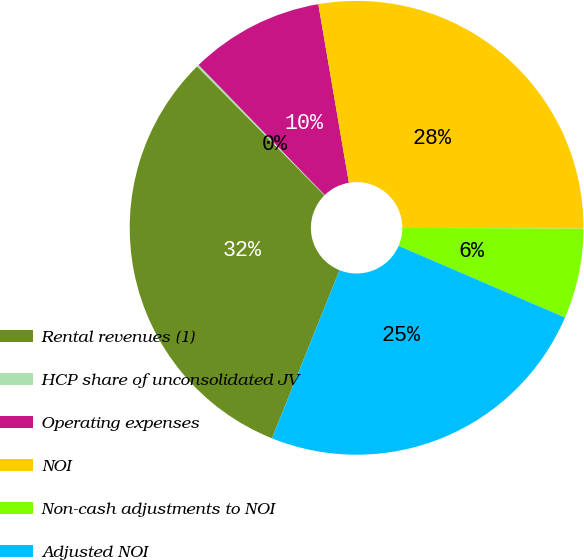Convert chart. <chart><loc_0><loc_0><loc_500><loc_500><pie_chart><fcel>Rental revenues (1)<fcel>HCP share of unconsolidated JV<fcel>Operating expenses<fcel>NOI<fcel>Non-cash adjustments to NOI<fcel>Adjusted NOI<nl><fcel>31.51%<fcel>0.15%<fcel>9.56%<fcel>27.75%<fcel>6.42%<fcel>24.61%<nl></chart> 